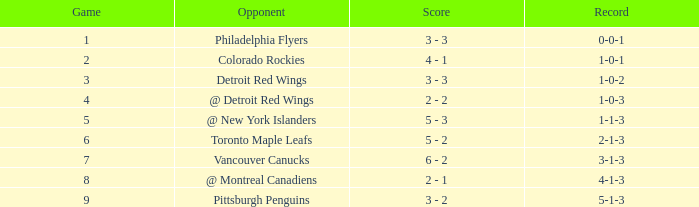Determine the minimum game having a 5-1-3 record. 9.0. 